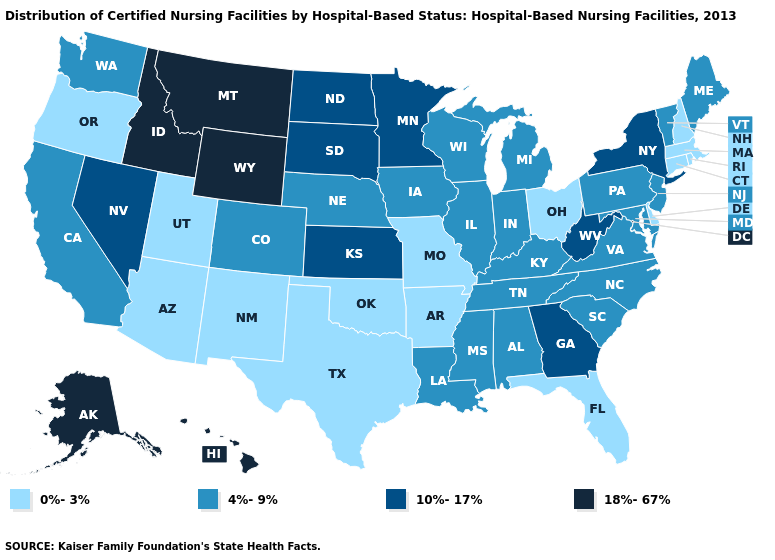Among the states that border Illinois , does Missouri have the lowest value?
Write a very short answer. Yes. What is the value of Hawaii?
Concise answer only. 18%-67%. Name the states that have a value in the range 0%-3%?
Concise answer only. Arizona, Arkansas, Connecticut, Delaware, Florida, Massachusetts, Missouri, New Hampshire, New Mexico, Ohio, Oklahoma, Oregon, Rhode Island, Texas, Utah. What is the value of New York?
Short answer required. 10%-17%. Which states have the highest value in the USA?
Short answer required. Alaska, Hawaii, Idaho, Montana, Wyoming. Name the states that have a value in the range 18%-67%?
Quick response, please. Alaska, Hawaii, Idaho, Montana, Wyoming. Does Maryland have the same value as Georgia?
Answer briefly. No. What is the value of Nebraska?
Write a very short answer. 4%-9%. What is the highest value in states that border Kentucky?
Short answer required. 10%-17%. What is the value of Texas?
Be succinct. 0%-3%. What is the value of Montana?
Answer briefly. 18%-67%. Name the states that have a value in the range 10%-17%?
Answer briefly. Georgia, Kansas, Minnesota, Nevada, New York, North Dakota, South Dakota, West Virginia. What is the value of Illinois?
Answer briefly. 4%-9%. 